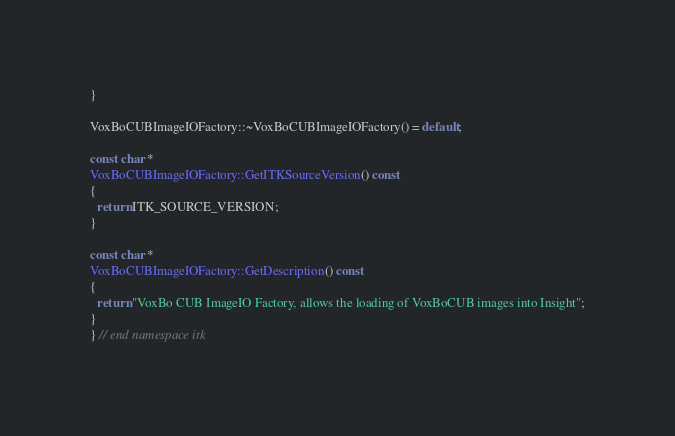<code> <loc_0><loc_0><loc_500><loc_500><_C++_>}

VoxBoCUBImageIOFactory::~VoxBoCUBImageIOFactory() = default;

const char *
VoxBoCUBImageIOFactory::GetITKSourceVersion() const
{
  return ITK_SOURCE_VERSION;
}

const char *
VoxBoCUBImageIOFactory::GetDescription() const
{
  return "VoxBo CUB ImageIO Factory, allows the loading of VoxBoCUB images into Insight";
}
} // end namespace itk
</code> 